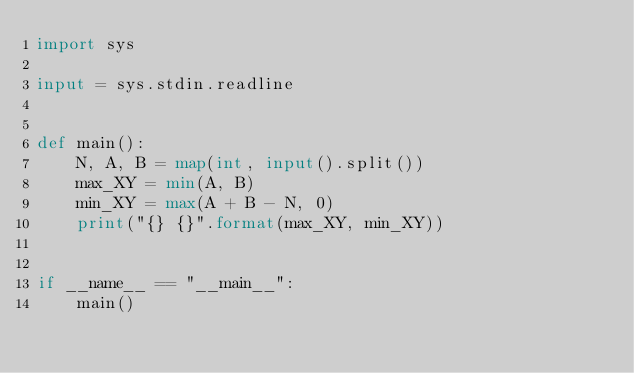Convert code to text. <code><loc_0><loc_0><loc_500><loc_500><_Python_>import sys

input = sys.stdin.readline


def main():
    N, A, B = map(int, input().split())
    max_XY = min(A, B)
    min_XY = max(A + B - N, 0)
    print("{} {}".format(max_XY, min_XY))


if __name__ == "__main__":
    main()
</code> 